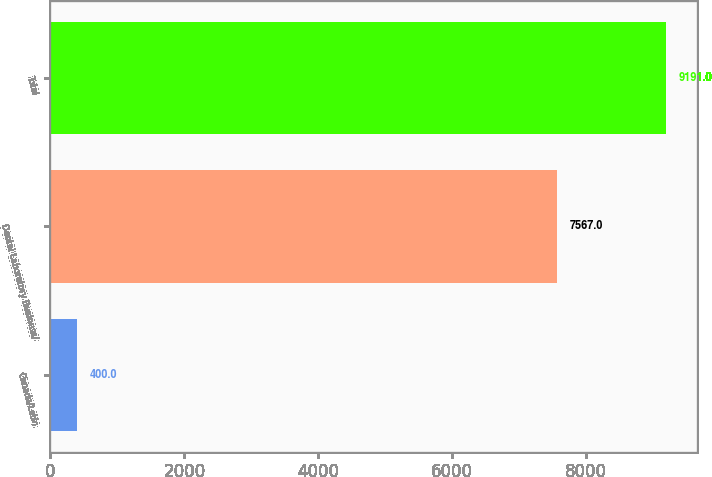<chart> <loc_0><loc_0><loc_500><loc_500><bar_chart><fcel>Canada/Latin<fcel>Dental Laboratory Business/<fcel>Total<nl><fcel>400<fcel>7567<fcel>9191<nl></chart> 